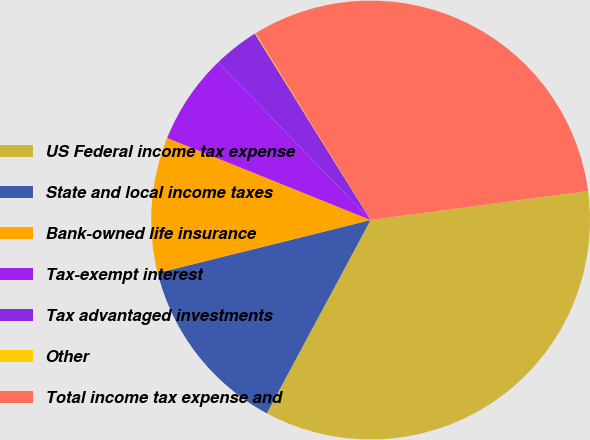Convert chart. <chart><loc_0><loc_0><loc_500><loc_500><pie_chart><fcel>US Federal income tax expense<fcel>State and local income taxes<fcel>Bank-owned life insurance<fcel>Tax-exempt interest<fcel>Tax advantaged investments<fcel>Other<fcel>Total income tax expense and<nl><fcel>34.96%<fcel>13.28%<fcel>9.98%<fcel>6.68%<fcel>3.38%<fcel>0.07%<fcel>31.66%<nl></chart> 